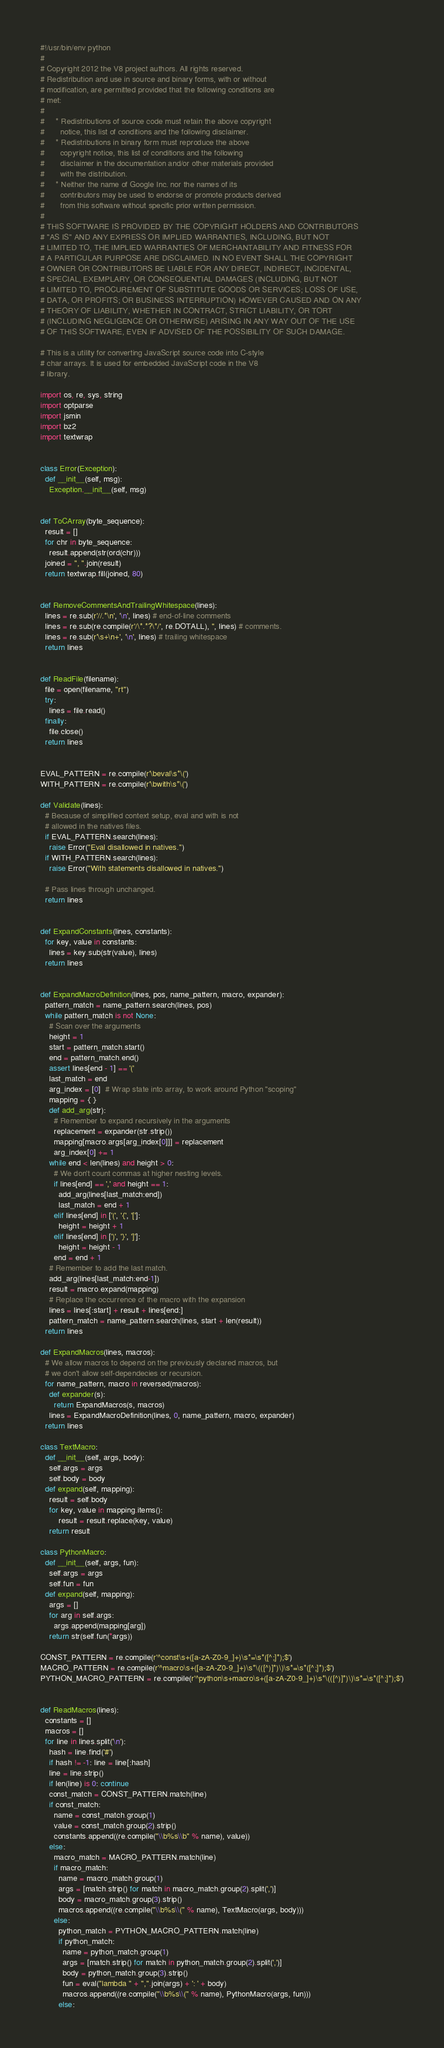<code> <loc_0><loc_0><loc_500><loc_500><_Python_>#!/usr/bin/env python
#
# Copyright 2012 the V8 project authors. All rights reserved.
# Redistribution and use in source and binary forms, with or without
# modification, are permitted provided that the following conditions are
# met:
#
#     * Redistributions of source code must retain the above copyright
#       notice, this list of conditions and the following disclaimer.
#     * Redistributions in binary form must reproduce the above
#       copyright notice, this list of conditions and the following
#       disclaimer in the documentation and/or other materials provided
#       with the distribution.
#     * Neither the name of Google Inc. nor the names of its
#       contributors may be used to endorse or promote products derived
#       from this software without specific prior written permission.
#
# THIS SOFTWARE IS PROVIDED BY THE COPYRIGHT HOLDERS AND CONTRIBUTORS
# "AS IS" AND ANY EXPRESS OR IMPLIED WARRANTIES, INCLUDING, BUT NOT
# LIMITED TO, THE IMPLIED WARRANTIES OF MERCHANTABILITY AND FITNESS FOR
# A PARTICULAR PURPOSE ARE DISCLAIMED. IN NO EVENT SHALL THE COPYRIGHT
# OWNER OR CONTRIBUTORS BE LIABLE FOR ANY DIRECT, INDIRECT, INCIDENTAL,
# SPECIAL, EXEMPLARY, OR CONSEQUENTIAL DAMAGES (INCLUDING, BUT NOT
# LIMITED TO, PROCUREMENT OF SUBSTITUTE GOODS OR SERVICES; LOSS OF USE,
# DATA, OR PROFITS; OR BUSINESS INTERRUPTION) HOWEVER CAUSED AND ON ANY
# THEORY OF LIABILITY, WHETHER IN CONTRACT, STRICT LIABILITY, OR TORT
# (INCLUDING NEGLIGENCE OR OTHERWISE) ARISING IN ANY WAY OUT OF THE USE
# OF THIS SOFTWARE, EVEN IF ADVISED OF THE POSSIBILITY OF SUCH DAMAGE.

# This is a utility for converting JavaScript source code into C-style
# char arrays. It is used for embedded JavaScript code in the V8
# library.

import os, re, sys, string
import optparse
import jsmin
import bz2
import textwrap


class Error(Exception):
  def __init__(self, msg):
    Exception.__init__(self, msg)


def ToCArray(byte_sequence):
  result = []
  for chr in byte_sequence:
    result.append(str(ord(chr)))
  joined = ", ".join(result)
  return textwrap.fill(joined, 80)


def RemoveCommentsAndTrailingWhitespace(lines):
  lines = re.sub(r'//.*\n', '\n', lines) # end-of-line comments
  lines = re.sub(re.compile(r'/\*.*?\*/', re.DOTALL), '', lines) # comments.
  lines = re.sub(r'\s+\n+', '\n', lines) # trailing whitespace
  return lines


def ReadFile(filename):
  file = open(filename, "rt")
  try:
    lines = file.read()
  finally:
    file.close()
  return lines


EVAL_PATTERN = re.compile(r'\beval\s*\(')
WITH_PATTERN = re.compile(r'\bwith\s*\(')

def Validate(lines):
  # Because of simplified context setup, eval and with is not
  # allowed in the natives files.
  if EVAL_PATTERN.search(lines):
    raise Error("Eval disallowed in natives.")
  if WITH_PATTERN.search(lines):
    raise Error("With statements disallowed in natives.")

  # Pass lines through unchanged.
  return lines


def ExpandConstants(lines, constants):
  for key, value in constants:
    lines = key.sub(str(value), lines)
  return lines


def ExpandMacroDefinition(lines, pos, name_pattern, macro, expander):
  pattern_match = name_pattern.search(lines, pos)
  while pattern_match is not None:
    # Scan over the arguments
    height = 1
    start = pattern_match.start()
    end = pattern_match.end()
    assert lines[end - 1] == '('
    last_match = end
    arg_index = [0]  # Wrap state into array, to work around Python "scoping"
    mapping = { }
    def add_arg(str):
      # Remember to expand recursively in the arguments
      replacement = expander(str.strip())
      mapping[macro.args[arg_index[0]]] = replacement
      arg_index[0] += 1
    while end < len(lines) and height > 0:
      # We don't count commas at higher nesting levels.
      if lines[end] == ',' and height == 1:
        add_arg(lines[last_match:end])
        last_match = end + 1
      elif lines[end] in ['(', '{', '[']:
        height = height + 1
      elif lines[end] in [')', '}', ']']:
        height = height - 1
      end = end + 1
    # Remember to add the last match.
    add_arg(lines[last_match:end-1])
    result = macro.expand(mapping)
    # Replace the occurrence of the macro with the expansion
    lines = lines[:start] + result + lines[end:]
    pattern_match = name_pattern.search(lines, start + len(result))
  return lines

def ExpandMacros(lines, macros):
  # We allow macros to depend on the previously declared macros, but
  # we don't allow self-dependecies or recursion.
  for name_pattern, macro in reversed(macros):
    def expander(s):
      return ExpandMacros(s, macros)
    lines = ExpandMacroDefinition(lines, 0, name_pattern, macro, expander)
  return lines

class TextMacro:
  def __init__(self, args, body):
    self.args = args
    self.body = body
  def expand(self, mapping):
    result = self.body
    for key, value in mapping.items():
        result = result.replace(key, value)
    return result

class PythonMacro:
  def __init__(self, args, fun):
    self.args = args
    self.fun = fun
  def expand(self, mapping):
    args = []
    for arg in self.args:
      args.append(mapping[arg])
    return str(self.fun(*args))

CONST_PATTERN = re.compile(r'^const\s+([a-zA-Z0-9_]+)\s*=\s*([^;]*);$')
MACRO_PATTERN = re.compile(r'^macro\s+([a-zA-Z0-9_]+)\s*\(([^)]*)\)\s*=\s*([^;]*);$')
PYTHON_MACRO_PATTERN = re.compile(r'^python\s+macro\s+([a-zA-Z0-9_]+)\s*\(([^)]*)\)\s*=\s*([^;]*);$')


def ReadMacros(lines):
  constants = []
  macros = []
  for line in lines.split('\n'):
    hash = line.find('#')
    if hash != -1: line = line[:hash]
    line = line.strip()
    if len(line) is 0: continue
    const_match = CONST_PATTERN.match(line)
    if const_match:
      name = const_match.group(1)
      value = const_match.group(2).strip()
      constants.append((re.compile("\\b%s\\b" % name), value))
    else:
      macro_match = MACRO_PATTERN.match(line)
      if macro_match:
        name = macro_match.group(1)
        args = [match.strip() for match in macro_match.group(2).split(',')]
        body = macro_match.group(3).strip()
        macros.append((re.compile("\\b%s\\(" % name), TextMacro(args, body)))
      else:
        python_match = PYTHON_MACRO_PATTERN.match(line)
        if python_match:
          name = python_match.group(1)
          args = [match.strip() for match in python_match.group(2).split(',')]
          body = python_match.group(3).strip()
          fun = eval("lambda " + ",".join(args) + ': ' + body)
          macros.append((re.compile("\\b%s\\(" % name), PythonMacro(args, fun)))
        else:</code> 